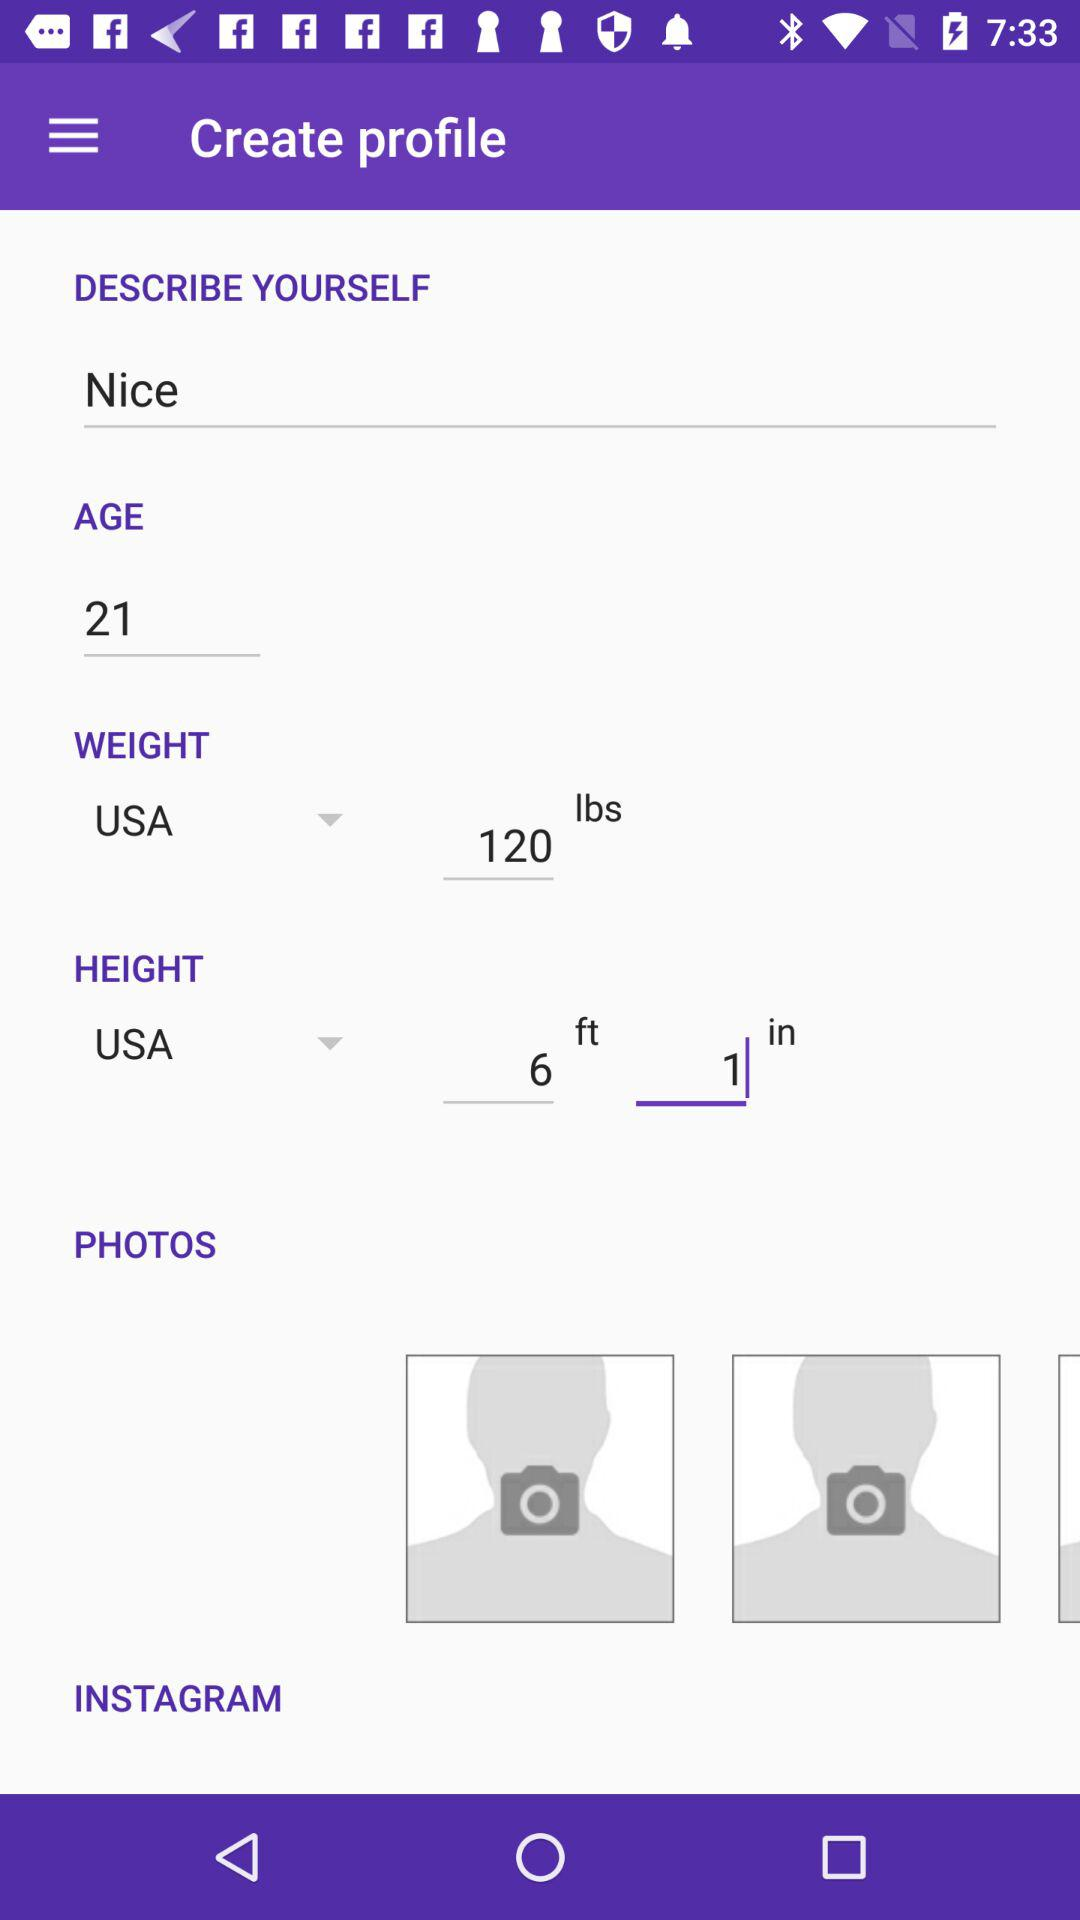What's the measuring unit of weight? The measuring unit of weight is pounds. 